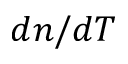<formula> <loc_0><loc_0><loc_500><loc_500>d n / d T</formula> 